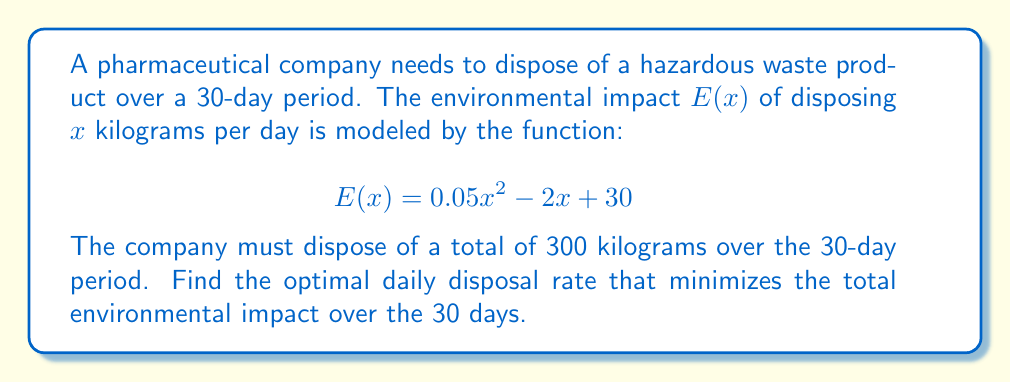Show me your answer to this math problem. To solve this optimization problem, we need to follow these steps:

1) First, we need to set up the objective function. The total environmental impact over 30 days is:

   $$30 \cdot E(x) = 30(0.05x^2 - 2x + 30) = 1.5x^2 - 60x + 900$$

2) We have a constraint that the total amount disposed over 30 days must be 300 kg:

   $$30x = 300$$
   $$x = 10$$

3) Since we have only one possible value for x, this is our optimal solution. However, let's verify this using calculus:

4) The derivative of the total impact function is:

   $$\frac{d}{dx}(1.5x^2 - 60x + 900) = 3x - 60$$

5) Setting this equal to zero:

   $$3x - 60 = 0$$
   $$3x = 60$$
   $$x = 20$$

6) The second derivative is positive (3 > 0), confirming this is a minimum.

7) However, this solution doesn't satisfy our constraint. The constrained minimum must occur at the boundary of our constraint, which is x = 10.

8) Therefore, the optimal disposal rate is 10 kg per day.

9) We can calculate the total environmental impact:

   $$E(10) = 0.05(10)^2 - 2(10) + 30 = 5 - 20 + 30 = 15$$

   Total impact over 30 days: $30 \cdot 15 = 450$
Answer: The optimal disposal rate is 10 kg per day, resulting in a total environmental impact of 450 units over the 30-day period. 